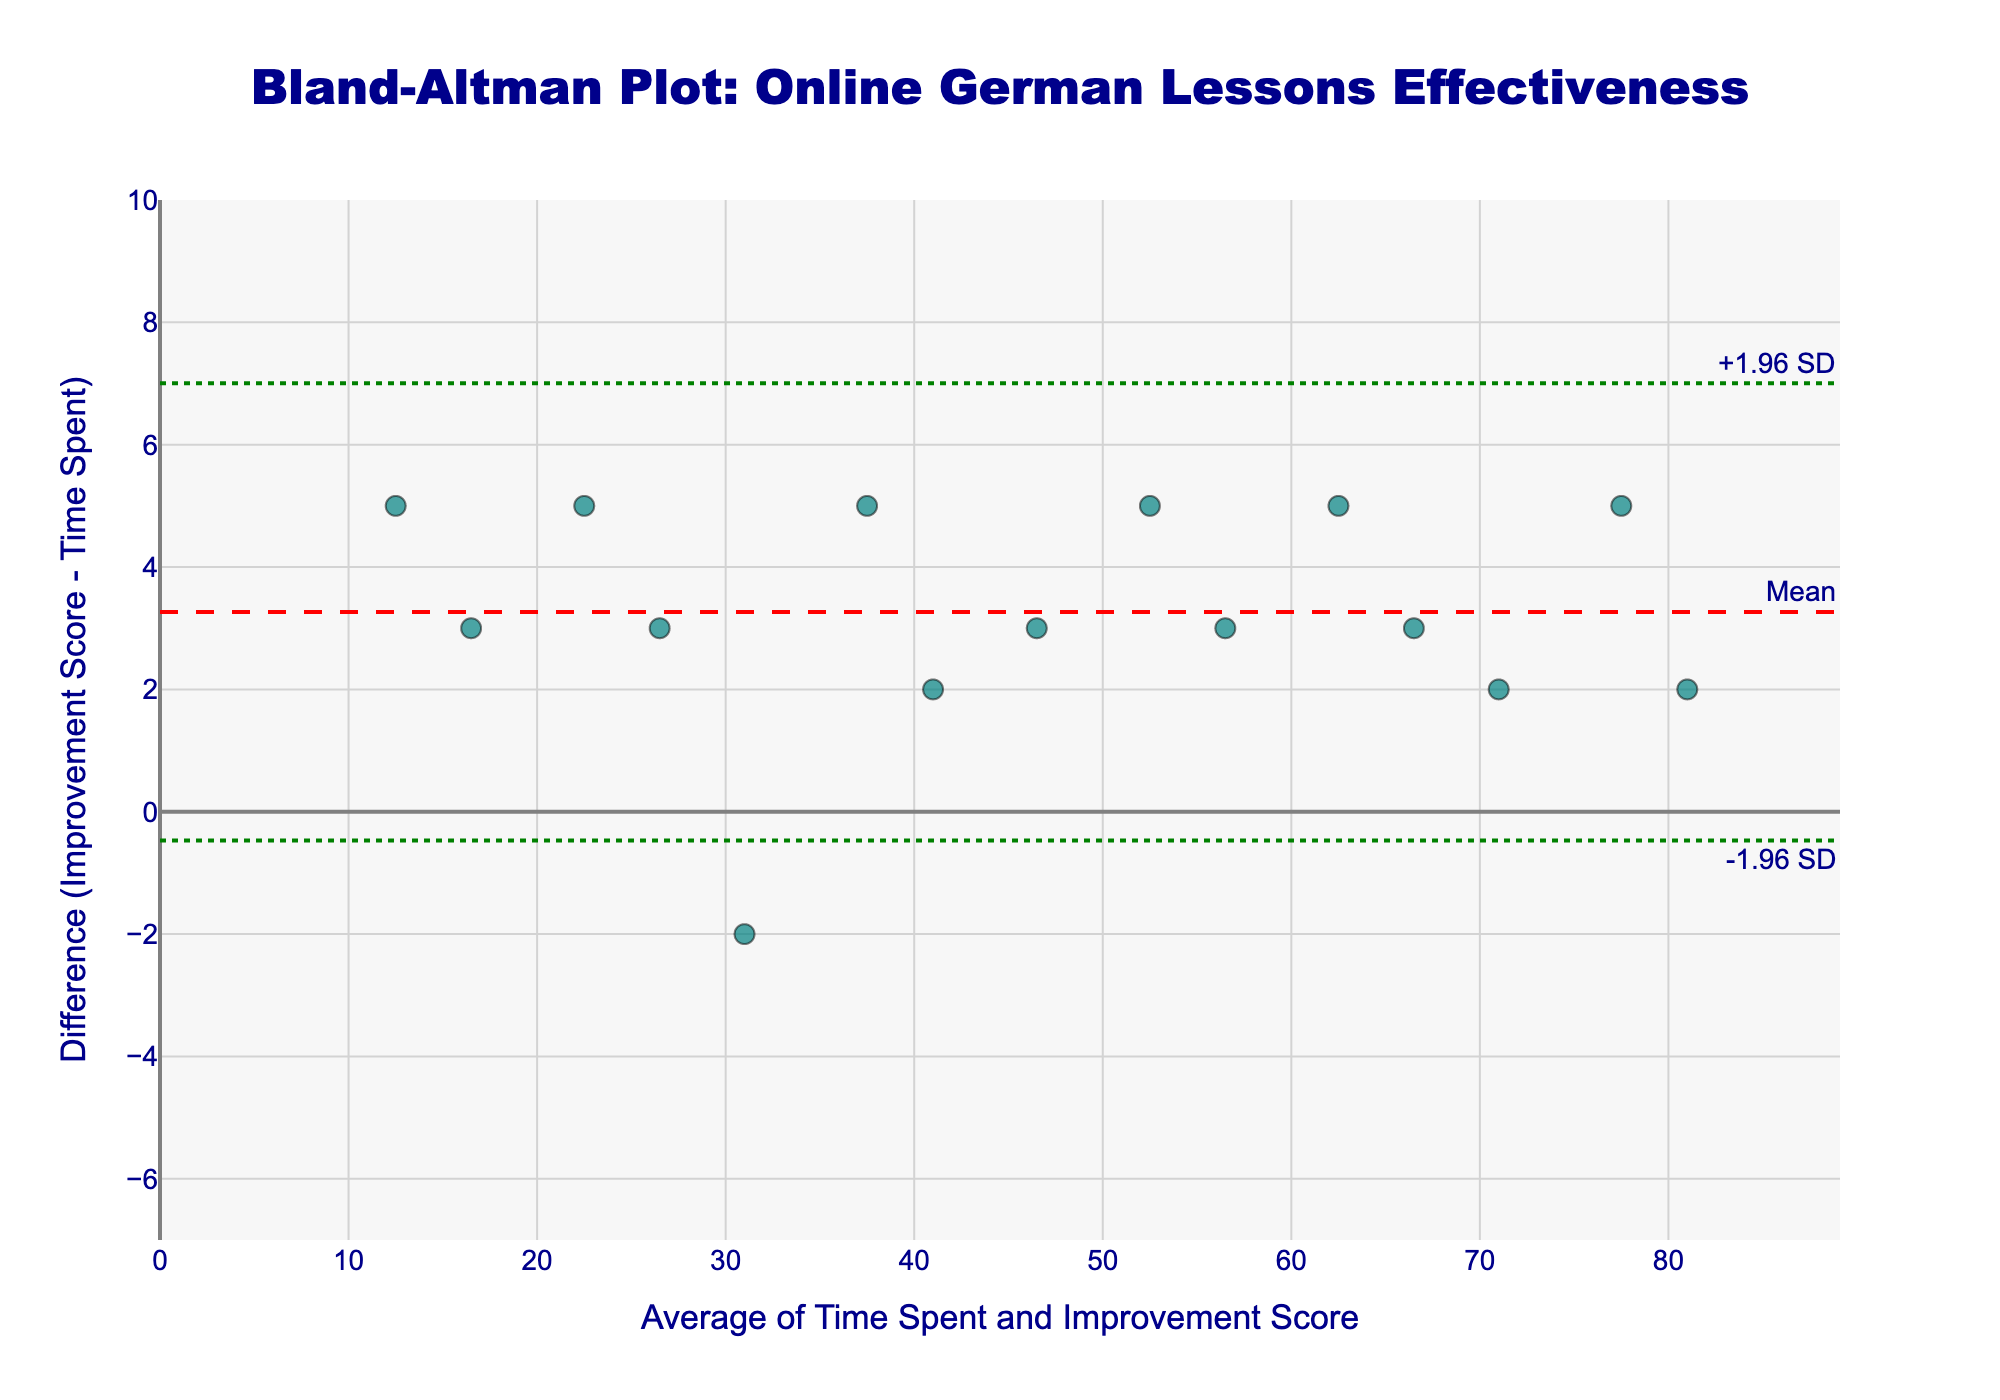What's the title of the plot? The title of the plot is mentioned at the top of the figure.
Answer: Bland-Altman Plot: Online German Lessons Effectiveness What is the color of the data points? By looking at the color of the markers representing the data points in the figure, we see that they are teal.
Answer: Teal How many horizontal lines are present in the figure? The figure contains one dashed line representing the mean difference and two dotted lines that represent ±1.96 standard deviations from the mean difference. This sums up to three horizontal lines.
Answer: Three What is the mean difference value? The mean difference value is annotated next to the red dashed line across the plot, which represents the mean difference of the data points.
Answer: 3.2 Are there more data points above the mean line or below it? By counting the data points visually above and below the mean line (red dashed line), we can compare the numbers. There are 9 points above the mean line and 6 points below it.
Answer: Above What are the ranges on the x-axis and y-axis? The range on the x-axis is from 0 to 90 (approximated to cover more than the maximum value of 81), and on the y-axis, it is from -7 to 10 (to cover more than the max difference values observed).
Answer: x: 0 - 90, y: -7 - 10 Which data point represents the highest improvement score? By checking the values and corresponding points, the highest improvement score is 82, occurring with an average of 81 on the x-axis.
Answer: 81 average, 82 improvement Is there a data point where the difference is negative? If so, which one? By looking at the difference values along the y-axis, there's one data point significantly below the x-axis; it represents a negative difference value, -2, corresponding to the sample with an average value of 31.
Answer: Yes, average 31 Which data point lies closest to the y-axis origin? The data point closest to the origin lies at the x-axis value where the difference between improvement score and time spent is minimal. One such point is where the average is 41, and the difference is 2.
Answer: 41 average, 2 difference What's the range of the data points' average values with a difference of 5? Looking at the data points marked at y = 5, we identify their x-axis values (10, 22.5, 37.5, 52.5, 77.5); the range is between the minimum and maximum of these values.
Answer: 10 to 77.5 Compare the mean difference to the boundary lines' values. Which is higher? The boundary lines represent mean ± 1.96*SD, calculated to be higher or lower than the mean. The mean is 3.2, boundary lines are 3.2 ± 3.06; thus, the upper boundary is higher.
Answer: Upper boundary is higher 